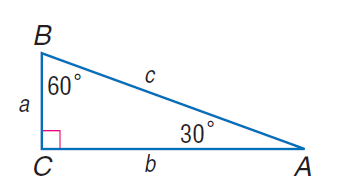Question: If b = 18, find a.
Choices:
A. 9
B. 6 \sqrt { 3 }
C. 9 \sqrt { 3 }
D. 12 \sqrt { 3 }
Answer with the letter. Answer: B Question: If c = 8, find b.
Choices:
A. 4
B. 4 \sqrt { 3 }
C. 8
D. 8 \sqrt { 3 }
Answer with the letter. Answer: B Question: If c = 8, find a.
Choices:
A. 4
B. 4 \sqrt { 3 }
C. 8
D. 8 \sqrt { 3 }
Answer with the letter. Answer: A Question: If b = 18, find c.
Choices:
A. 9
B. 6 \sqrt { 3 }
C. 18
D. 12 \sqrt { 3 }
Answer with the letter. Answer: D 